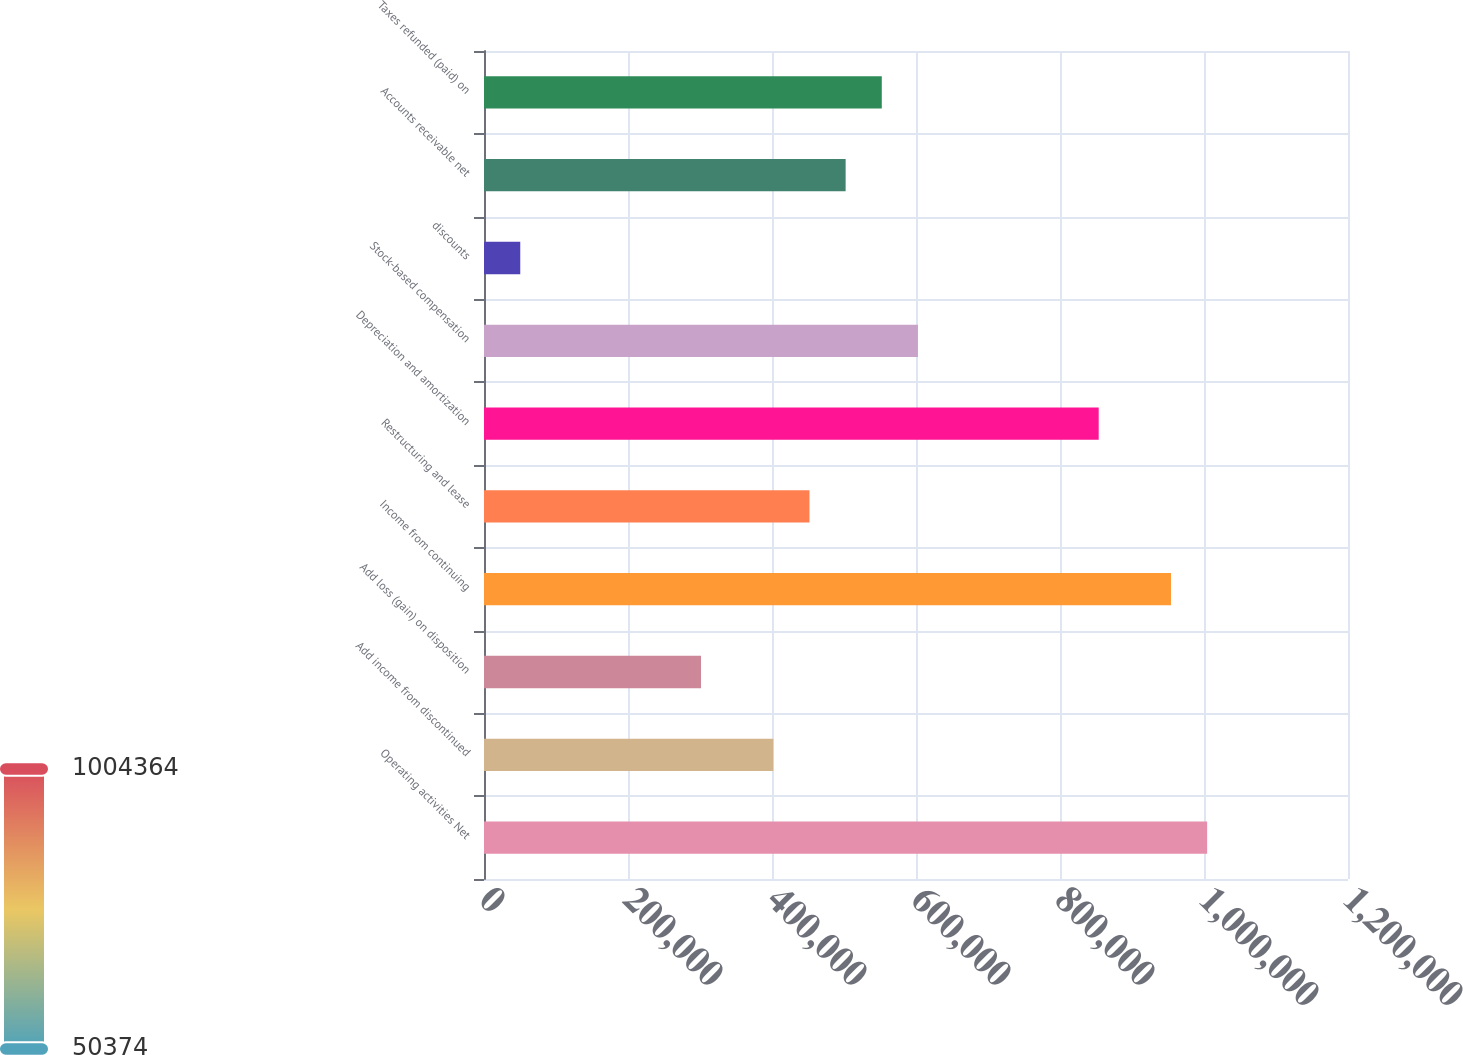Convert chart to OTSL. <chart><loc_0><loc_0><loc_500><loc_500><bar_chart><fcel>Operating activities Net<fcel>Add income from discontinued<fcel>Add loss (gain) on disposition<fcel>Income from continuing<fcel>Restructuring and lease<fcel>Depreciation and amortization<fcel>Stock-based compensation<fcel>discounts<fcel>Accounts receivable net<fcel>Taxes refunded (paid) on<nl><fcel>1.00436e+06<fcel>401844<fcel>301424<fcel>954154<fcel>452054<fcel>853734<fcel>602684<fcel>50374<fcel>502264<fcel>552474<nl></chart> 